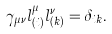<formula> <loc_0><loc_0><loc_500><loc_500>\gamma _ { \mu \nu } l ^ { \mu } _ { ( i ) } l ^ { \nu } _ { ( k ) } = \delta _ { i k } .</formula> 